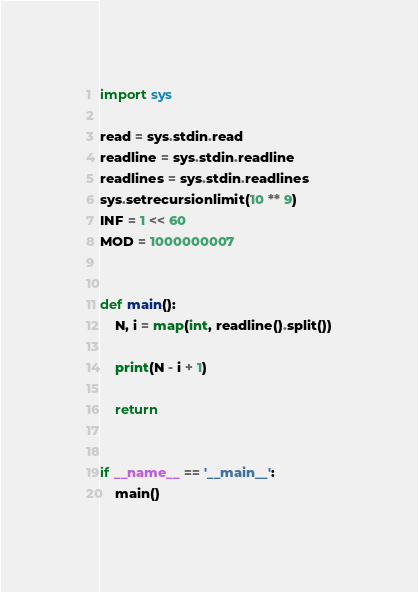<code> <loc_0><loc_0><loc_500><loc_500><_Python_>import sys

read = sys.stdin.read
readline = sys.stdin.readline
readlines = sys.stdin.readlines
sys.setrecursionlimit(10 ** 9)
INF = 1 << 60
MOD = 1000000007


def main():
    N, i = map(int, readline().split())

    print(N - i + 1)

    return


if __name__ == '__main__':
    main()
</code> 